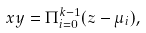Convert formula to latex. <formula><loc_0><loc_0><loc_500><loc_500>x y = \Pi _ { i = 0 } ^ { k - 1 } ( z - \mu _ { i } ) ,</formula> 